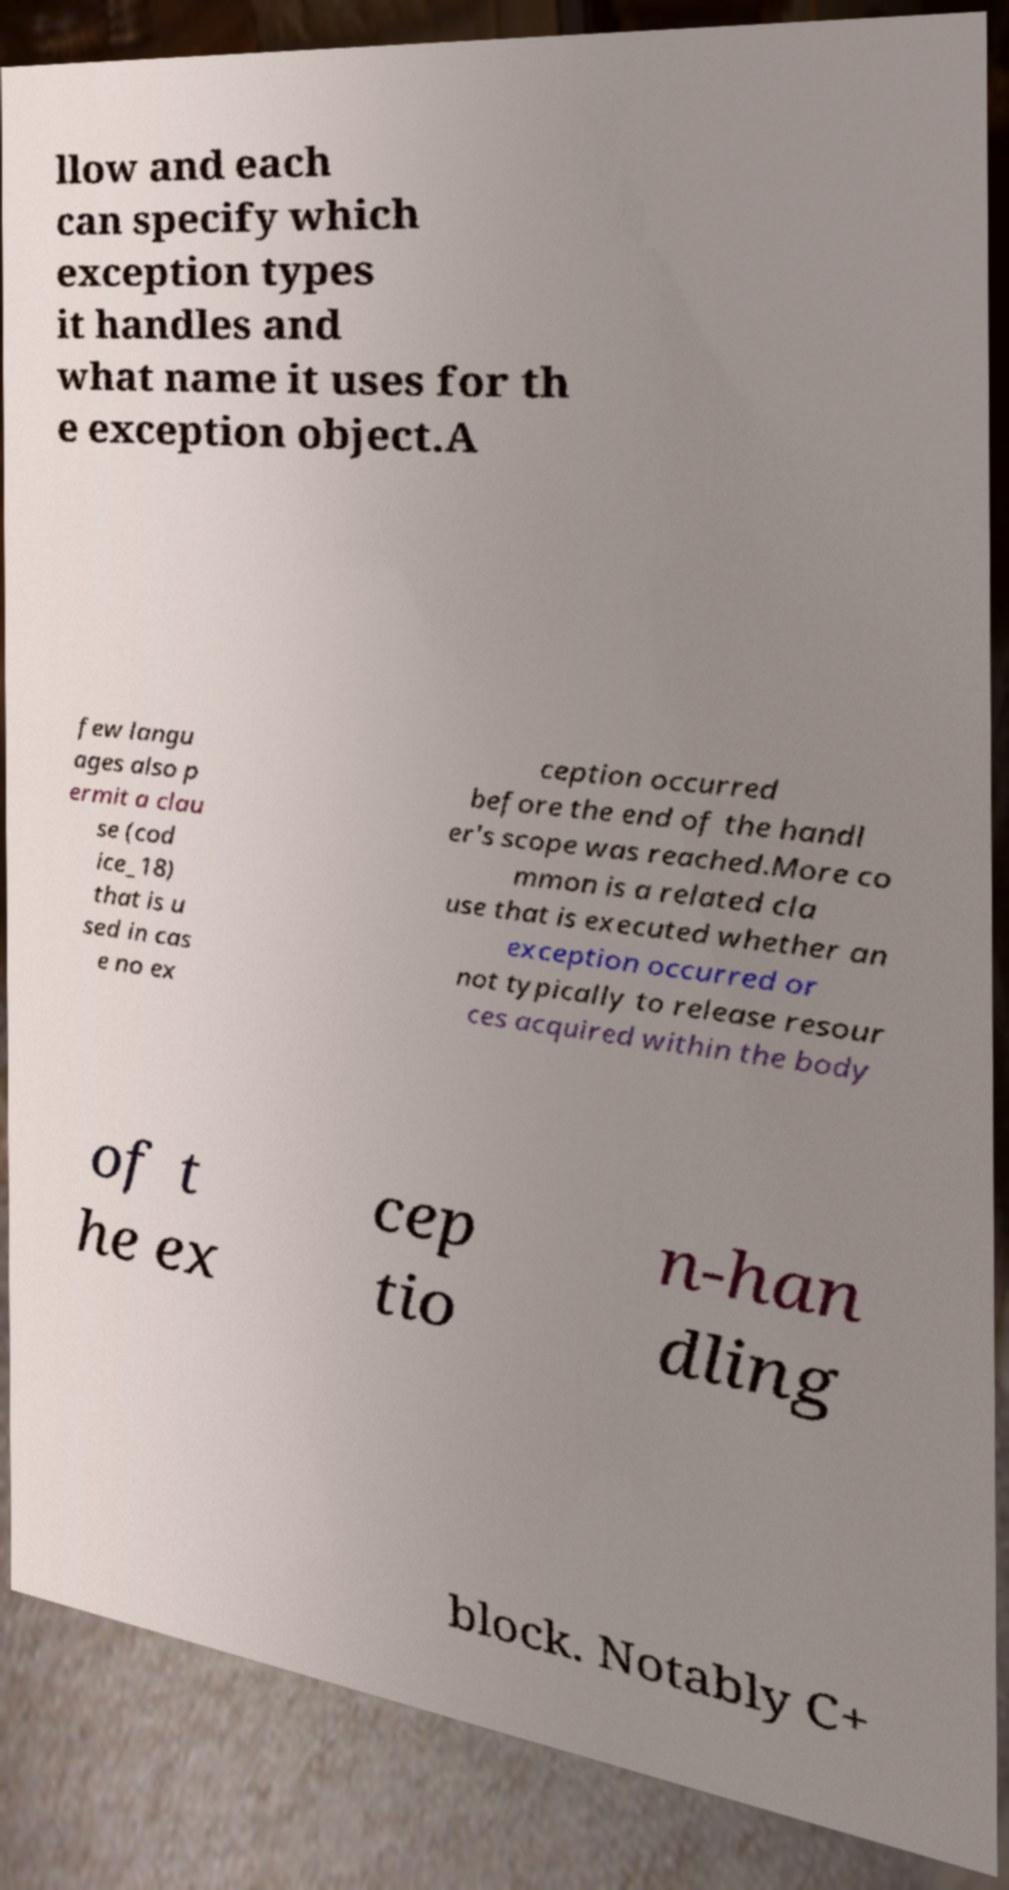Could you assist in decoding the text presented in this image and type it out clearly? llow and each can specify which exception types it handles and what name it uses for th e exception object.A few langu ages also p ermit a clau se (cod ice_18) that is u sed in cas e no ex ception occurred before the end of the handl er's scope was reached.More co mmon is a related cla use that is executed whether an exception occurred or not typically to release resour ces acquired within the body of t he ex cep tio n-han dling block. Notably C+ 